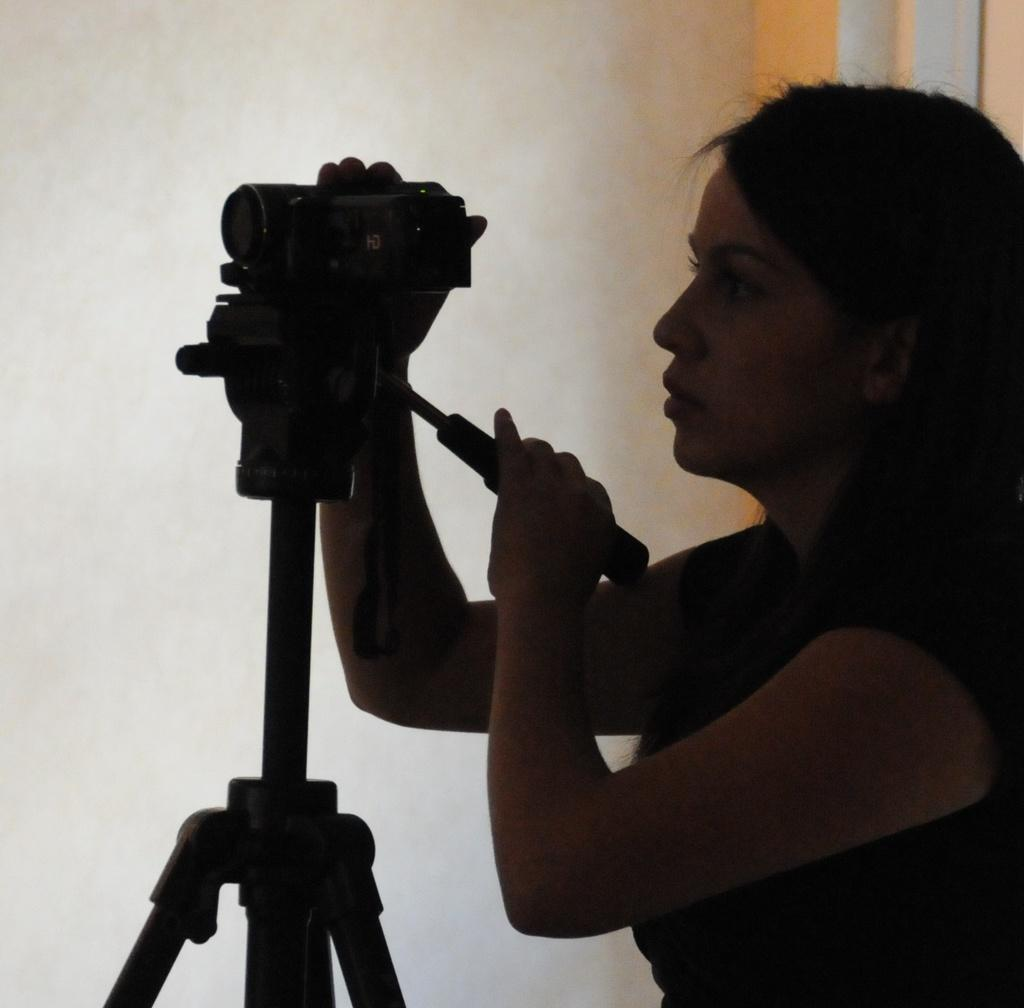What is the main subject of the image? There is a person in the image. What is the person holding in the image? The person is holding a camera. How is the camera positioned in the image? The camera is on a tripod stand. What can be seen in the background of the image? There is a wall in the background of the image. What type of birds can be seen flying in the wilderness in the image? There are no birds or wilderness present in the image; it features a person holding a camera on a tripod stand with a wall in the background. 